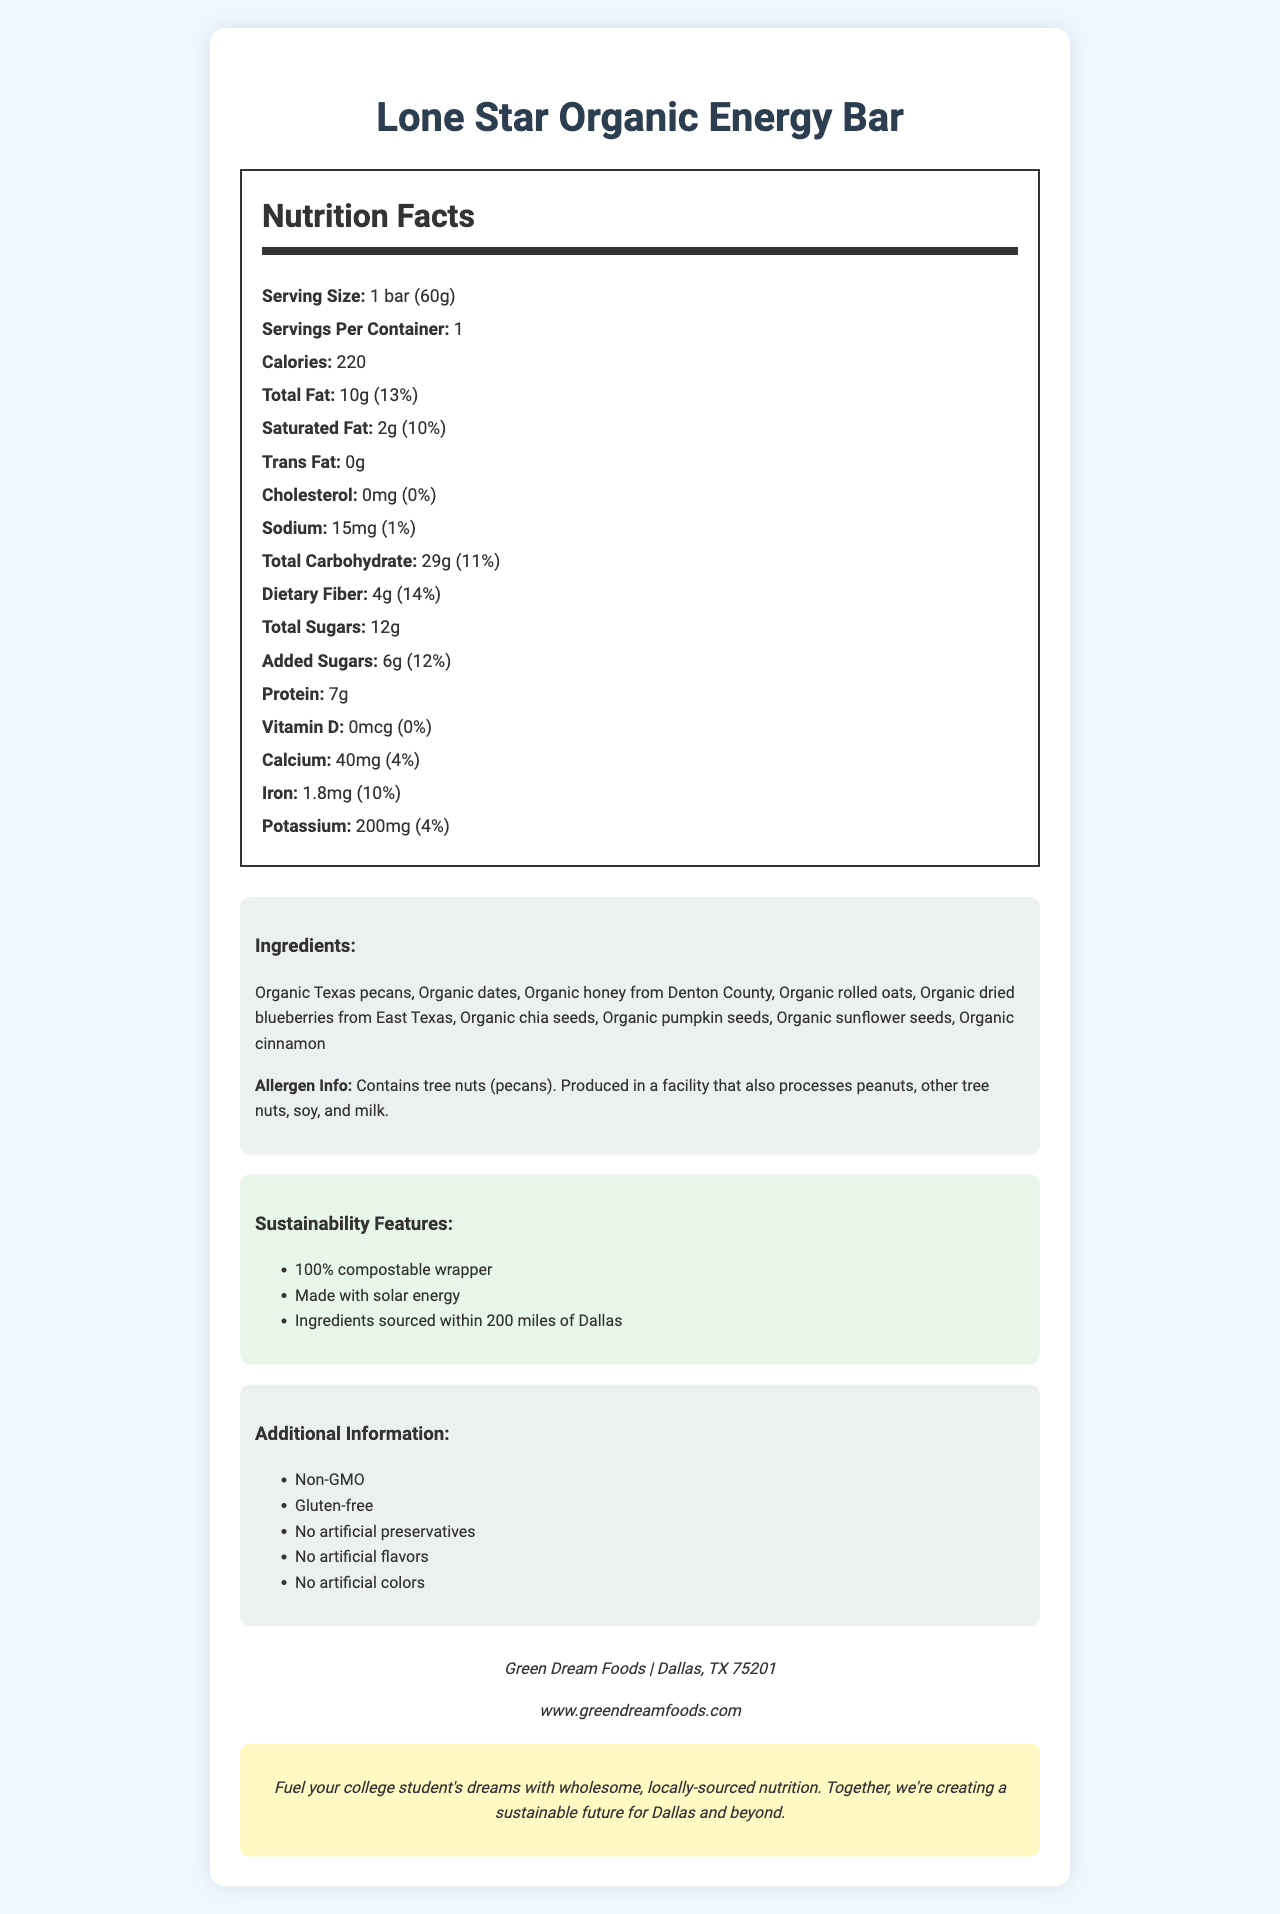what is the serving size for the Lone Star Organic Energy Bar? The serving size is listed as "1 bar (60g)" in the Nutrition Facts section of the document.
Answer: 1 bar (60g) how many calories are in one serving of the snack bar? The document lists "Calories: 220" for one serving size.
Answer: 220 what is the percentage of daily value for total fat? According to the Nutrition Facts, the total fat amount is "10g" which is 13% of the daily value.
Answer: 13% how much protein does the Lone Star Organic Energy Bar contain? The protein content is stated as "7g" in the Nutrition Facts.
Answer: 7g what ingredients are used in the Lone Star Organic Energy Bar? The ingredients are listed under the Ingredients section.
Answer: Organic Texas pecans, Organic dates, Organic honey from Denton County, Organic rolled oats, Organic dried blueberries from East Texas, Organic chia seeds, Organic pumpkin seeds, Organic sunflower seeds, Organic cinnamon which sustainable feature is mentioned in the document? A. Recyclable wrapper B. Made with solar energy C. Sourced from international suppliers D. Made with wind energy The document lists "Made with solar energy" as one of the sustainability features.
Answer: B what is the sodium content per serving? The sodium content is listed as "Sodium: 15mg (1%)" in the Nutrition Facts.
Answer: 15mg is the Lone Star Organic Energy Bar gluten-free? The document mentions "Gluten-free" under the Additional Information section.
Answer: Yes what allergens are present in the Lone Star Organic Energy Bar? The allergen information specifies that it contains tree nuts (pecans) and is produced in a facility that also processes peanuts, other tree nuts, soy, and milk.
Answer: Tree nuts (pecans) describe the main idea of this document. The document includes detailed nutritional information, ingredients, allergen info, sustainability features, and additional information about the Lone Star Organic Energy Bar, promoting it as a nutritious and sustainably produced snack.
Answer: The document provides detailed nutrition facts for the Lone Star Organic Energy Bar, including ingredients, allergen information, sustainability features, and additional information. The bar emphasizes local sourcing and sustainable practices, making it a healthy and eco-friendly snack option. is there any information about vitamin C in this document? The document does not mention vitamin C in the Nutrition Facts section.
Answer: No how much dietary fiber does one serving of the snack bar provide? The dietary fiber content is listed as "Dietary Fiber: 4g (14%)" in the Nutrition Facts.
Answer: 4g what is the company that produces the Lone Star Organic Energy Bar? A. Organic Foods Inc. B. Green Dream Foods C. Nature's Path D. Healthy Snacks Co. The document lists the company as "Green Dream Foods" in the Company Info section.
Answer: B what is the potassium daily value percentage? The potassium content is listed as "Potassium: 200mg (4%)" in the Nutrition Facts.
Answer: 4% what kind of packaging does the snack bar use? The Sustainability Features section mentions that the wrapper is 100% compostable.
Answer: 100% compostable wrapper are there any artificial flavors in the Lone Star Organic Energy Bar? The document states "No artificial flavors" under the Additional Information section.
Answer: No what is the web address for Green Dream Foods? The Company Info section provides the website as "www.greendreamfoods.com".
Answer: www.greendreamfoods.com what is the percentage of daily value for added sugars? A. 10% B. 12% C. 15% D. 5% The document lists "Added Sugars: 6g (12%)" in the Nutrition Facts.
Answer: B where are the blueberries in the bar sourced from? The Ingredients section specifies "Organic dried blueberries from East Texas".
Answer: East Texas does the document provide information on how the energy bar impacts blood sugar levels after consumption? The document does not provide any information about the impact of consuming the bar on blood sugar levels.
Answer: Not enough information 